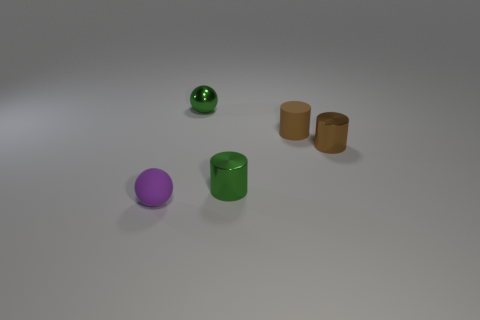Does the shiny ball have the same color as the metallic cylinder that is in front of the small brown shiny cylinder?
Offer a very short reply. Yes. There is a brown thing that is made of the same material as the tiny purple object; what is its size?
Offer a very short reply. Small. Is there a object of the same color as the small metal ball?
Offer a very short reply. Yes. How many things are either cylinders to the right of the small green cylinder or tiny red matte objects?
Offer a terse response. 2. Are the green sphere and the brown object that is to the right of the small brown rubber cylinder made of the same material?
Make the answer very short. Yes. Are there any brown things made of the same material as the small green sphere?
Give a very brief answer. Yes. How many things are either tiny matte things behind the tiny purple thing or green shiny objects that are right of the green shiny ball?
Your answer should be compact. 2. There is a small brown rubber object; does it have the same shape as the tiny brown object right of the brown rubber cylinder?
Provide a short and direct response. Yes. What number of other objects are there of the same shape as the tiny brown rubber object?
Your response must be concise. 2. What number of things are either small brown rubber objects or big brown rubber cylinders?
Your answer should be very brief. 1. 